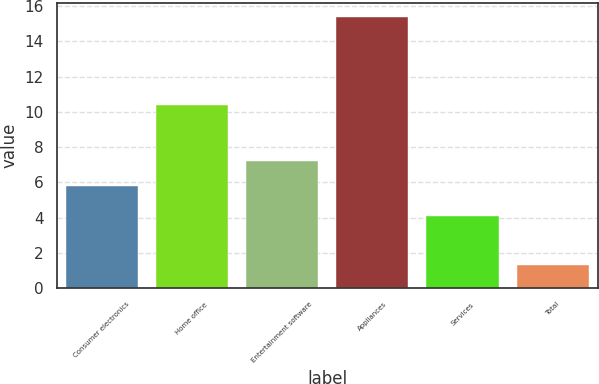Convert chart. <chart><loc_0><loc_0><loc_500><loc_500><bar_chart><fcel>Consumer electronics<fcel>Home office<fcel>Entertainment software<fcel>Appliances<fcel>Services<fcel>Total<nl><fcel>5.8<fcel>10.4<fcel>7.21<fcel>15.4<fcel>4.1<fcel>1.3<nl></chart> 